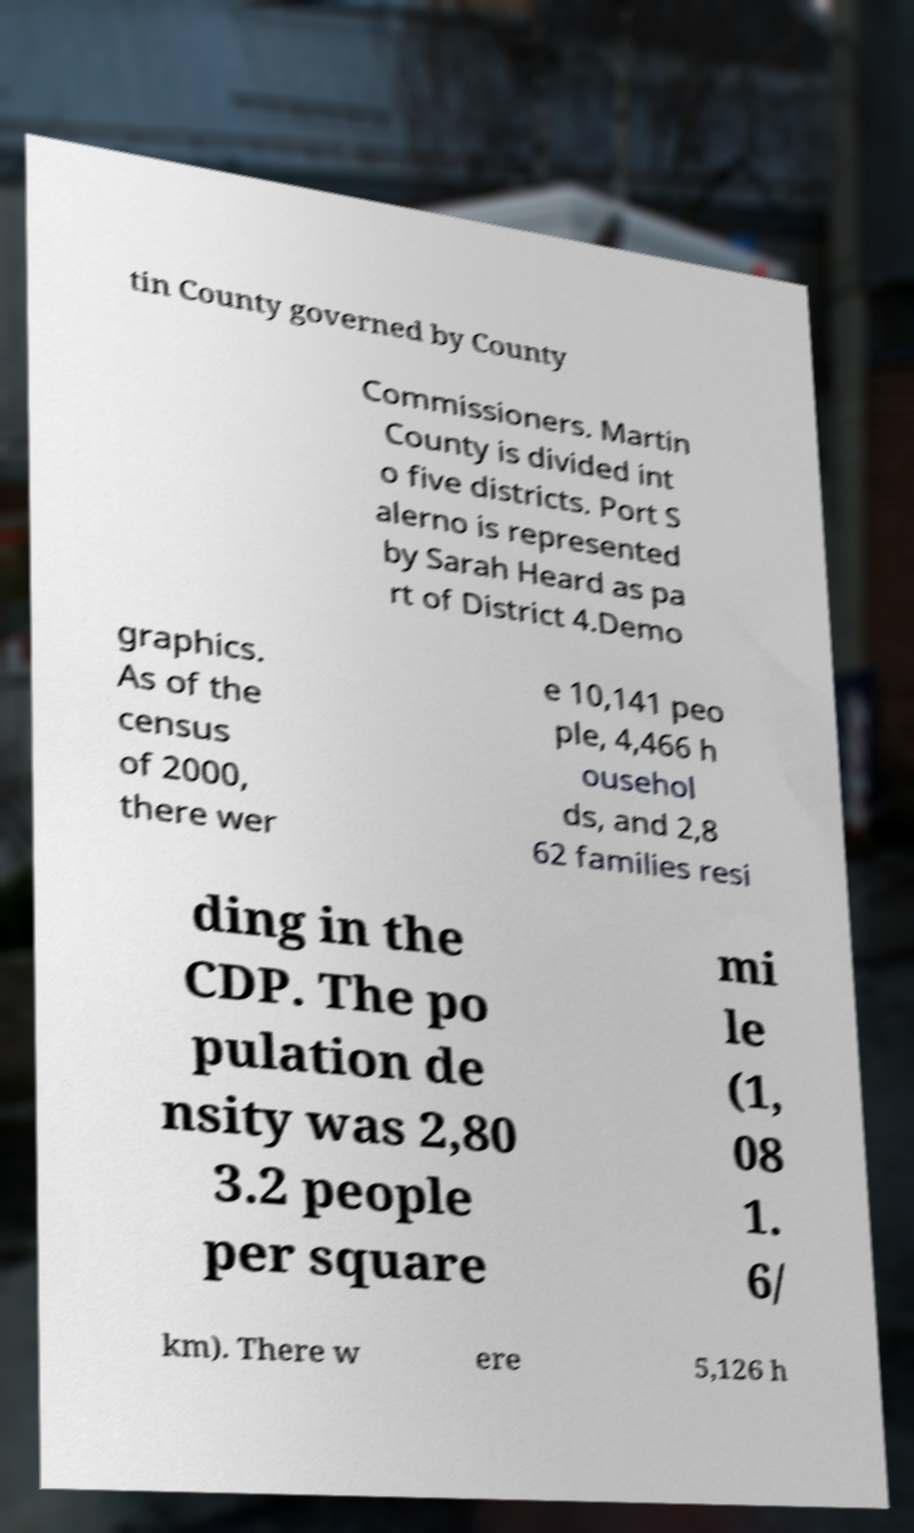There's text embedded in this image that I need extracted. Can you transcribe it verbatim? tin County governed by County Commissioners. Martin County is divided int o five districts. Port S alerno is represented by Sarah Heard as pa rt of District 4.Demo graphics. As of the census of 2000, there wer e 10,141 peo ple, 4,466 h ousehol ds, and 2,8 62 families resi ding in the CDP. The po pulation de nsity was 2,80 3.2 people per square mi le (1, 08 1. 6/ km). There w ere 5,126 h 